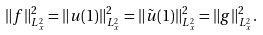Convert formula to latex. <formula><loc_0><loc_0><loc_500><loc_500>\| f \| _ { L ^ { 2 } _ { x } } ^ { 2 } = \| u ( 1 ) \| _ { L ^ { 2 } _ { x } } ^ { 2 } = \| \tilde { u } ( 1 ) \| _ { L ^ { 2 } _ { x } } ^ { 2 } = \| g \| _ { L ^ { 2 } _ { x } } ^ { 2 } .</formula> 